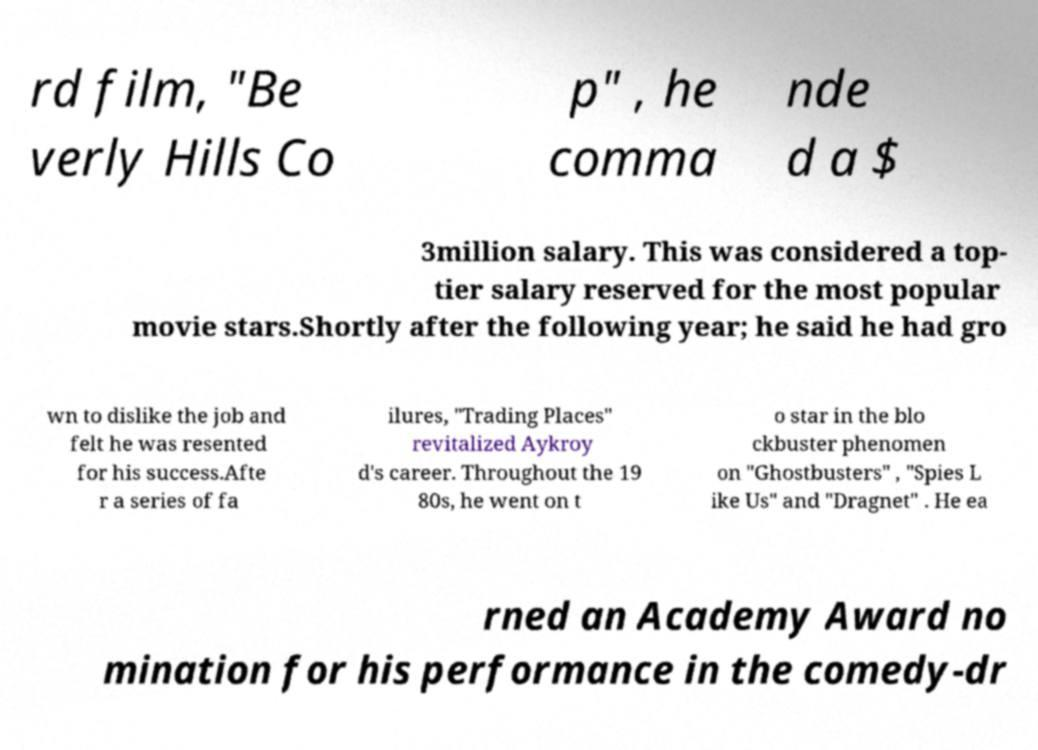Could you extract and type out the text from this image? rd film, "Be verly Hills Co p" , he comma nde d a $ 3million salary. This was considered a top- tier salary reserved for the most popular movie stars.Shortly after the following year; he said he had gro wn to dislike the job and felt he was resented for his success.Afte r a series of fa ilures, "Trading Places" revitalized Aykroy d's career. Throughout the 19 80s, he went on t o star in the blo ckbuster phenomen on "Ghostbusters" , "Spies L ike Us" and "Dragnet" . He ea rned an Academy Award no mination for his performance in the comedy-dr 